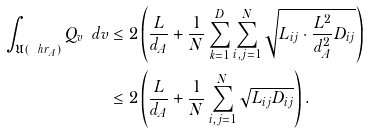Convert formula to latex. <formula><loc_0><loc_0><loc_500><loc_500>\int _ { \mathfrak { U } ( \ h r _ { A } ) } Q _ { v } \ d v & \leq 2 \left ( \frac { L } { d _ { A } } + \frac { 1 } { N } \sum _ { k = 1 } ^ { D } \sum _ { i , j = 1 } ^ { N } \sqrt { L _ { i j } \cdot \frac { L ^ { 2 } } { d _ { A } ^ { 2 } } D _ { i j } } \right ) \\ & \leq 2 \left ( \frac { L } { d _ { A } } + \frac { 1 } { N } \sum _ { i , j = 1 } ^ { N } \sqrt { L _ { i j } D _ { i j } } \right ) .</formula> 